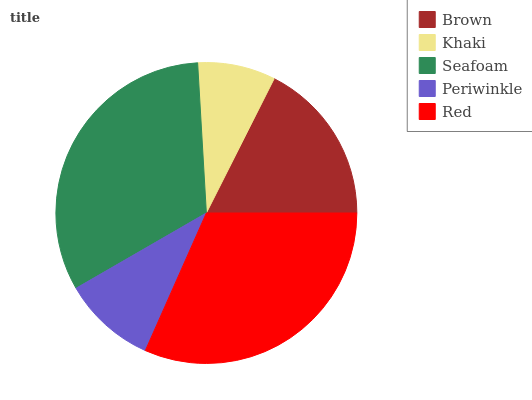Is Khaki the minimum?
Answer yes or no. Yes. Is Seafoam the maximum?
Answer yes or no. Yes. Is Seafoam the minimum?
Answer yes or no. No. Is Khaki the maximum?
Answer yes or no. No. Is Seafoam greater than Khaki?
Answer yes or no. Yes. Is Khaki less than Seafoam?
Answer yes or no. Yes. Is Khaki greater than Seafoam?
Answer yes or no. No. Is Seafoam less than Khaki?
Answer yes or no. No. Is Brown the high median?
Answer yes or no. Yes. Is Brown the low median?
Answer yes or no. Yes. Is Periwinkle the high median?
Answer yes or no. No. Is Periwinkle the low median?
Answer yes or no. No. 